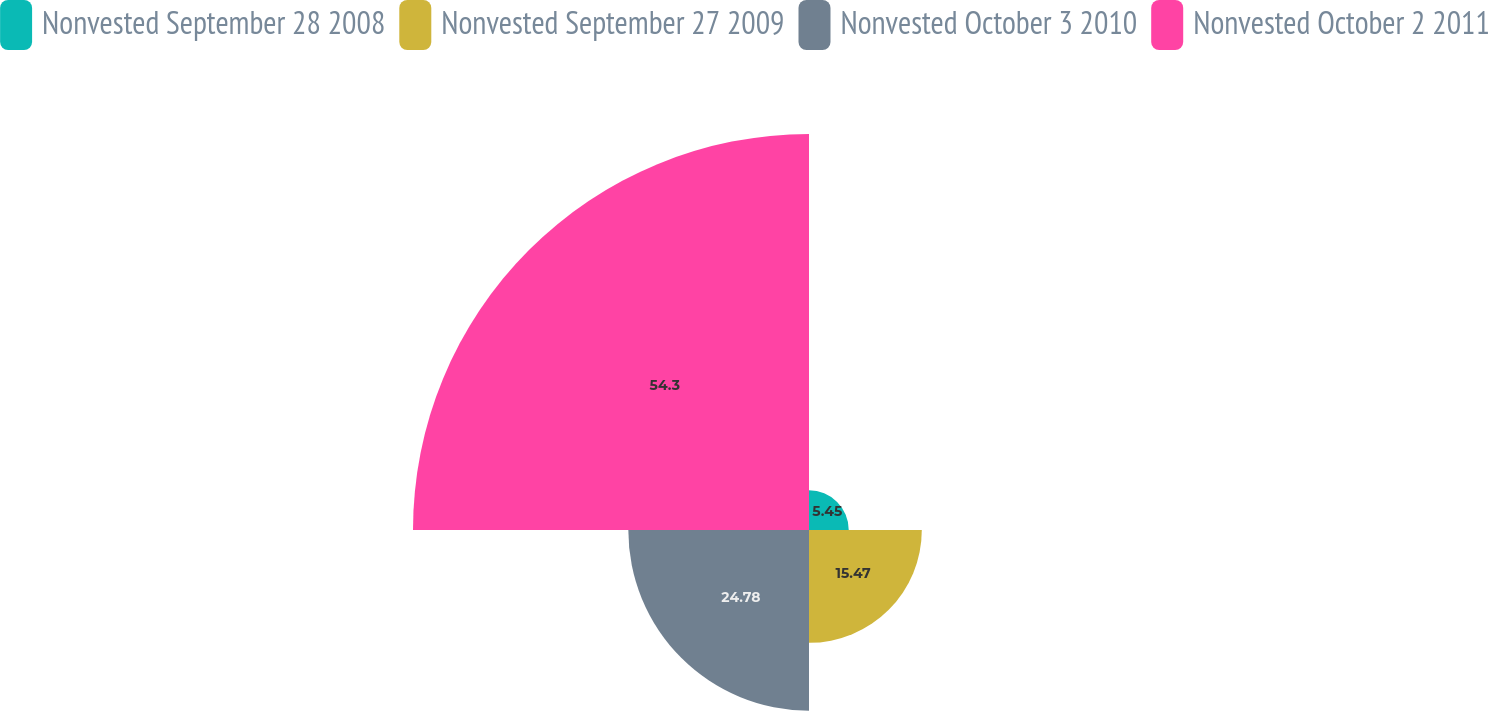Convert chart to OTSL. <chart><loc_0><loc_0><loc_500><loc_500><pie_chart><fcel>Nonvested September 28 2008<fcel>Nonvested September 27 2009<fcel>Nonvested October 3 2010<fcel>Nonvested October 2 2011<nl><fcel>5.45%<fcel>15.47%<fcel>24.78%<fcel>54.31%<nl></chart> 